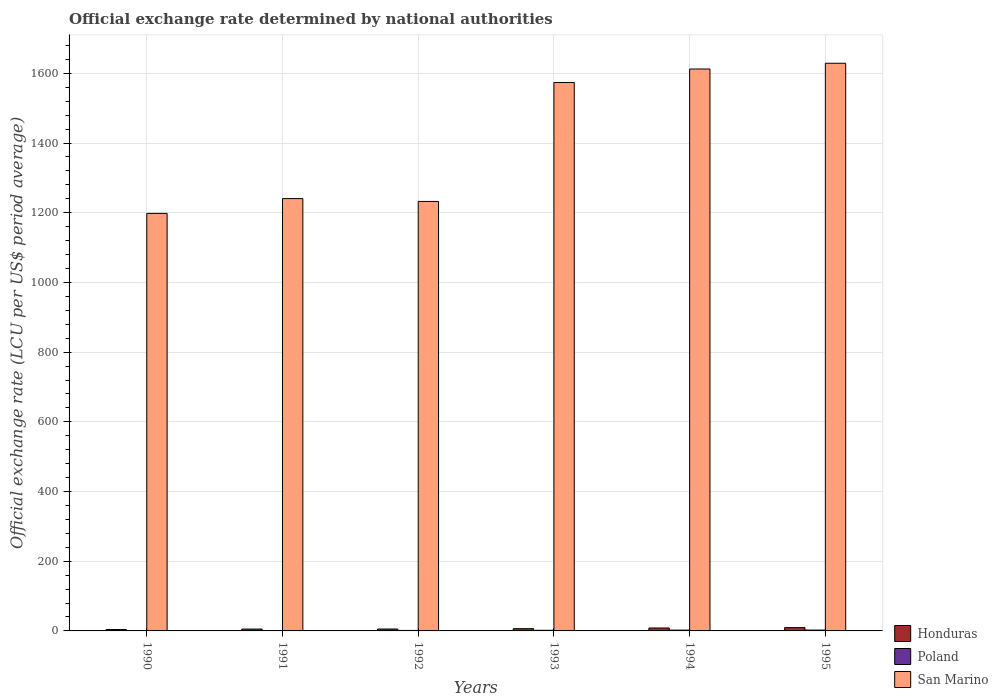How many different coloured bars are there?
Offer a terse response. 3. How many groups of bars are there?
Your answer should be compact. 6. How many bars are there on the 2nd tick from the right?
Keep it short and to the point. 3. What is the label of the 4th group of bars from the left?
Your answer should be compact. 1993. What is the official exchange rate in San Marino in 1992?
Make the answer very short. 1232.41. Across all years, what is the maximum official exchange rate in Poland?
Offer a very short reply. 2.42. Across all years, what is the minimum official exchange rate in Honduras?
Offer a very short reply. 4.11. What is the total official exchange rate in San Marino in the graph?
Give a very brief answer. 8486.16. What is the difference between the official exchange rate in Poland in 1991 and that in 1993?
Your answer should be very brief. -0.75. What is the difference between the official exchange rate in Honduras in 1991 and the official exchange rate in San Marino in 1994?
Your response must be concise. -1607.13. What is the average official exchange rate in Honduras per year?
Give a very brief answer. 6.55. In the year 1992, what is the difference between the official exchange rate in San Marino and official exchange rate in Honduras?
Ensure brevity in your answer.  1226.91. In how many years, is the official exchange rate in Honduras greater than 800 LCU?
Your response must be concise. 0. What is the ratio of the official exchange rate in Honduras in 1990 to that in 1995?
Offer a very short reply. 0.43. Is the official exchange rate in San Marino in 1990 less than that in 1991?
Give a very brief answer. Yes. What is the difference between the highest and the second highest official exchange rate in Poland?
Provide a succinct answer. 0.15. What is the difference between the highest and the lowest official exchange rate in Poland?
Keep it short and to the point. 1.47. In how many years, is the official exchange rate in Poland greater than the average official exchange rate in Poland taken over all years?
Provide a succinct answer. 3. Is the sum of the official exchange rate in Poland in 1994 and 1995 greater than the maximum official exchange rate in Honduras across all years?
Offer a terse response. No. What does the 2nd bar from the right in 1992 represents?
Your response must be concise. Poland. How many years are there in the graph?
Offer a very short reply. 6. Are the values on the major ticks of Y-axis written in scientific E-notation?
Offer a terse response. No. Where does the legend appear in the graph?
Ensure brevity in your answer.  Bottom right. What is the title of the graph?
Make the answer very short. Official exchange rate determined by national authorities. Does "Ukraine" appear as one of the legend labels in the graph?
Make the answer very short. No. What is the label or title of the X-axis?
Provide a succinct answer. Years. What is the label or title of the Y-axis?
Ensure brevity in your answer.  Official exchange rate (LCU per US$ period average). What is the Official exchange rate (LCU per US$ period average) of Honduras in 1990?
Keep it short and to the point. 4.11. What is the Official exchange rate (LCU per US$ period average) of Poland in 1990?
Provide a succinct answer. 0.95. What is the Official exchange rate (LCU per US$ period average) of San Marino in 1990?
Give a very brief answer. 1198.1. What is the Official exchange rate (LCU per US$ period average) in Honduras in 1991?
Provide a succinct answer. 5.32. What is the Official exchange rate (LCU per US$ period average) in Poland in 1991?
Give a very brief answer. 1.06. What is the Official exchange rate (LCU per US$ period average) of San Marino in 1991?
Offer a terse response. 1240.61. What is the Official exchange rate (LCU per US$ period average) in Honduras in 1992?
Make the answer very short. 5.5. What is the Official exchange rate (LCU per US$ period average) of Poland in 1992?
Ensure brevity in your answer.  1.36. What is the Official exchange rate (LCU per US$ period average) of San Marino in 1992?
Give a very brief answer. 1232.41. What is the Official exchange rate (LCU per US$ period average) of Honduras in 1993?
Provide a succinct answer. 6.47. What is the Official exchange rate (LCU per US$ period average) of Poland in 1993?
Provide a succinct answer. 1.81. What is the Official exchange rate (LCU per US$ period average) of San Marino in 1993?
Your answer should be compact. 1573.67. What is the Official exchange rate (LCU per US$ period average) in Honduras in 1994?
Your answer should be very brief. 8.41. What is the Official exchange rate (LCU per US$ period average) of Poland in 1994?
Provide a succinct answer. 2.27. What is the Official exchange rate (LCU per US$ period average) of San Marino in 1994?
Ensure brevity in your answer.  1612.44. What is the Official exchange rate (LCU per US$ period average) of Honduras in 1995?
Your answer should be very brief. 9.47. What is the Official exchange rate (LCU per US$ period average) of Poland in 1995?
Your answer should be compact. 2.42. What is the Official exchange rate (LCU per US$ period average) in San Marino in 1995?
Offer a very short reply. 1628.93. Across all years, what is the maximum Official exchange rate (LCU per US$ period average) of Honduras?
Ensure brevity in your answer.  9.47. Across all years, what is the maximum Official exchange rate (LCU per US$ period average) in Poland?
Your answer should be very brief. 2.42. Across all years, what is the maximum Official exchange rate (LCU per US$ period average) in San Marino?
Provide a short and direct response. 1628.93. Across all years, what is the minimum Official exchange rate (LCU per US$ period average) in Honduras?
Keep it short and to the point. 4.11. Across all years, what is the minimum Official exchange rate (LCU per US$ period average) of Poland?
Give a very brief answer. 0.95. Across all years, what is the minimum Official exchange rate (LCU per US$ period average) of San Marino?
Offer a terse response. 1198.1. What is the total Official exchange rate (LCU per US$ period average) of Honduras in the graph?
Make the answer very short. 39.28. What is the total Official exchange rate (LCU per US$ period average) of Poland in the graph?
Ensure brevity in your answer.  9.88. What is the total Official exchange rate (LCU per US$ period average) of San Marino in the graph?
Offer a very short reply. 8486.16. What is the difference between the Official exchange rate (LCU per US$ period average) in Honduras in 1990 and that in 1991?
Make the answer very short. -1.2. What is the difference between the Official exchange rate (LCU per US$ period average) in Poland in 1990 and that in 1991?
Provide a succinct answer. -0.11. What is the difference between the Official exchange rate (LCU per US$ period average) in San Marino in 1990 and that in 1991?
Provide a succinct answer. -42.51. What is the difference between the Official exchange rate (LCU per US$ period average) in Honduras in 1990 and that in 1992?
Offer a very short reply. -1.39. What is the difference between the Official exchange rate (LCU per US$ period average) of Poland in 1990 and that in 1992?
Offer a terse response. -0.41. What is the difference between the Official exchange rate (LCU per US$ period average) in San Marino in 1990 and that in 1992?
Keep it short and to the point. -34.3. What is the difference between the Official exchange rate (LCU per US$ period average) of Honduras in 1990 and that in 1993?
Your response must be concise. -2.36. What is the difference between the Official exchange rate (LCU per US$ period average) in Poland in 1990 and that in 1993?
Offer a very short reply. -0.86. What is the difference between the Official exchange rate (LCU per US$ period average) of San Marino in 1990 and that in 1993?
Ensure brevity in your answer.  -375.56. What is the difference between the Official exchange rate (LCU per US$ period average) in Honduras in 1990 and that in 1994?
Provide a short and direct response. -4.3. What is the difference between the Official exchange rate (LCU per US$ period average) of Poland in 1990 and that in 1994?
Provide a succinct answer. -1.32. What is the difference between the Official exchange rate (LCU per US$ period average) in San Marino in 1990 and that in 1994?
Your answer should be very brief. -414.34. What is the difference between the Official exchange rate (LCU per US$ period average) of Honduras in 1990 and that in 1995?
Provide a succinct answer. -5.36. What is the difference between the Official exchange rate (LCU per US$ period average) of Poland in 1990 and that in 1995?
Give a very brief answer. -1.48. What is the difference between the Official exchange rate (LCU per US$ period average) in San Marino in 1990 and that in 1995?
Make the answer very short. -430.83. What is the difference between the Official exchange rate (LCU per US$ period average) in Honduras in 1991 and that in 1992?
Offer a very short reply. -0.18. What is the difference between the Official exchange rate (LCU per US$ period average) of Poland in 1991 and that in 1992?
Offer a very short reply. -0.3. What is the difference between the Official exchange rate (LCU per US$ period average) of San Marino in 1991 and that in 1992?
Offer a very short reply. 8.21. What is the difference between the Official exchange rate (LCU per US$ period average) in Honduras in 1991 and that in 1993?
Ensure brevity in your answer.  -1.15. What is the difference between the Official exchange rate (LCU per US$ period average) of Poland in 1991 and that in 1993?
Provide a succinct answer. -0.75. What is the difference between the Official exchange rate (LCU per US$ period average) of San Marino in 1991 and that in 1993?
Your answer should be very brief. -333.05. What is the difference between the Official exchange rate (LCU per US$ period average) of Honduras in 1991 and that in 1994?
Provide a short and direct response. -3.09. What is the difference between the Official exchange rate (LCU per US$ period average) of Poland in 1991 and that in 1994?
Make the answer very short. -1.21. What is the difference between the Official exchange rate (LCU per US$ period average) of San Marino in 1991 and that in 1994?
Offer a terse response. -371.83. What is the difference between the Official exchange rate (LCU per US$ period average) of Honduras in 1991 and that in 1995?
Offer a terse response. -4.15. What is the difference between the Official exchange rate (LCU per US$ period average) of Poland in 1991 and that in 1995?
Your answer should be very brief. -1.37. What is the difference between the Official exchange rate (LCU per US$ period average) of San Marino in 1991 and that in 1995?
Make the answer very short. -388.32. What is the difference between the Official exchange rate (LCU per US$ period average) of Honduras in 1992 and that in 1993?
Your answer should be very brief. -0.97. What is the difference between the Official exchange rate (LCU per US$ period average) in Poland in 1992 and that in 1993?
Keep it short and to the point. -0.45. What is the difference between the Official exchange rate (LCU per US$ period average) of San Marino in 1992 and that in 1993?
Ensure brevity in your answer.  -341.26. What is the difference between the Official exchange rate (LCU per US$ period average) in Honduras in 1992 and that in 1994?
Make the answer very short. -2.91. What is the difference between the Official exchange rate (LCU per US$ period average) in Poland in 1992 and that in 1994?
Offer a terse response. -0.91. What is the difference between the Official exchange rate (LCU per US$ period average) in San Marino in 1992 and that in 1994?
Keep it short and to the point. -380.04. What is the difference between the Official exchange rate (LCU per US$ period average) in Honduras in 1992 and that in 1995?
Your response must be concise. -3.97. What is the difference between the Official exchange rate (LCU per US$ period average) in Poland in 1992 and that in 1995?
Offer a terse response. -1.06. What is the difference between the Official exchange rate (LCU per US$ period average) of San Marino in 1992 and that in 1995?
Provide a succinct answer. -396.53. What is the difference between the Official exchange rate (LCU per US$ period average) of Honduras in 1993 and that in 1994?
Keep it short and to the point. -1.94. What is the difference between the Official exchange rate (LCU per US$ period average) of Poland in 1993 and that in 1994?
Offer a very short reply. -0.46. What is the difference between the Official exchange rate (LCU per US$ period average) in San Marino in 1993 and that in 1994?
Offer a terse response. -38.78. What is the difference between the Official exchange rate (LCU per US$ period average) of Honduras in 1993 and that in 1995?
Ensure brevity in your answer.  -3. What is the difference between the Official exchange rate (LCU per US$ period average) of Poland in 1993 and that in 1995?
Keep it short and to the point. -0.61. What is the difference between the Official exchange rate (LCU per US$ period average) in San Marino in 1993 and that in 1995?
Offer a very short reply. -55.27. What is the difference between the Official exchange rate (LCU per US$ period average) in Honduras in 1994 and that in 1995?
Ensure brevity in your answer.  -1.06. What is the difference between the Official exchange rate (LCU per US$ period average) in Poland in 1994 and that in 1995?
Make the answer very short. -0.15. What is the difference between the Official exchange rate (LCU per US$ period average) of San Marino in 1994 and that in 1995?
Keep it short and to the point. -16.49. What is the difference between the Official exchange rate (LCU per US$ period average) of Honduras in 1990 and the Official exchange rate (LCU per US$ period average) of Poland in 1991?
Your answer should be compact. 3.05. What is the difference between the Official exchange rate (LCU per US$ period average) in Honduras in 1990 and the Official exchange rate (LCU per US$ period average) in San Marino in 1991?
Your response must be concise. -1236.5. What is the difference between the Official exchange rate (LCU per US$ period average) of Poland in 1990 and the Official exchange rate (LCU per US$ period average) of San Marino in 1991?
Your response must be concise. -1239.66. What is the difference between the Official exchange rate (LCU per US$ period average) of Honduras in 1990 and the Official exchange rate (LCU per US$ period average) of Poland in 1992?
Keep it short and to the point. 2.75. What is the difference between the Official exchange rate (LCU per US$ period average) of Honduras in 1990 and the Official exchange rate (LCU per US$ period average) of San Marino in 1992?
Ensure brevity in your answer.  -1228.29. What is the difference between the Official exchange rate (LCU per US$ period average) in Poland in 1990 and the Official exchange rate (LCU per US$ period average) in San Marino in 1992?
Your response must be concise. -1231.46. What is the difference between the Official exchange rate (LCU per US$ period average) in Honduras in 1990 and the Official exchange rate (LCU per US$ period average) in Poland in 1993?
Make the answer very short. 2.3. What is the difference between the Official exchange rate (LCU per US$ period average) of Honduras in 1990 and the Official exchange rate (LCU per US$ period average) of San Marino in 1993?
Your response must be concise. -1569.55. What is the difference between the Official exchange rate (LCU per US$ period average) in Poland in 1990 and the Official exchange rate (LCU per US$ period average) in San Marino in 1993?
Offer a terse response. -1572.72. What is the difference between the Official exchange rate (LCU per US$ period average) in Honduras in 1990 and the Official exchange rate (LCU per US$ period average) in Poland in 1994?
Your response must be concise. 1.84. What is the difference between the Official exchange rate (LCU per US$ period average) in Honduras in 1990 and the Official exchange rate (LCU per US$ period average) in San Marino in 1994?
Ensure brevity in your answer.  -1608.33. What is the difference between the Official exchange rate (LCU per US$ period average) of Poland in 1990 and the Official exchange rate (LCU per US$ period average) of San Marino in 1994?
Ensure brevity in your answer.  -1611.49. What is the difference between the Official exchange rate (LCU per US$ period average) in Honduras in 1990 and the Official exchange rate (LCU per US$ period average) in Poland in 1995?
Provide a short and direct response. 1.69. What is the difference between the Official exchange rate (LCU per US$ period average) in Honduras in 1990 and the Official exchange rate (LCU per US$ period average) in San Marino in 1995?
Make the answer very short. -1624.82. What is the difference between the Official exchange rate (LCU per US$ period average) in Poland in 1990 and the Official exchange rate (LCU per US$ period average) in San Marino in 1995?
Your response must be concise. -1627.98. What is the difference between the Official exchange rate (LCU per US$ period average) of Honduras in 1991 and the Official exchange rate (LCU per US$ period average) of Poland in 1992?
Give a very brief answer. 3.95. What is the difference between the Official exchange rate (LCU per US$ period average) of Honduras in 1991 and the Official exchange rate (LCU per US$ period average) of San Marino in 1992?
Give a very brief answer. -1227.09. What is the difference between the Official exchange rate (LCU per US$ period average) in Poland in 1991 and the Official exchange rate (LCU per US$ period average) in San Marino in 1992?
Offer a very short reply. -1231.35. What is the difference between the Official exchange rate (LCU per US$ period average) in Honduras in 1991 and the Official exchange rate (LCU per US$ period average) in Poland in 1993?
Ensure brevity in your answer.  3.51. What is the difference between the Official exchange rate (LCU per US$ period average) of Honduras in 1991 and the Official exchange rate (LCU per US$ period average) of San Marino in 1993?
Ensure brevity in your answer.  -1568.35. What is the difference between the Official exchange rate (LCU per US$ period average) in Poland in 1991 and the Official exchange rate (LCU per US$ period average) in San Marino in 1993?
Keep it short and to the point. -1572.61. What is the difference between the Official exchange rate (LCU per US$ period average) in Honduras in 1991 and the Official exchange rate (LCU per US$ period average) in Poland in 1994?
Make the answer very short. 3.04. What is the difference between the Official exchange rate (LCU per US$ period average) of Honduras in 1991 and the Official exchange rate (LCU per US$ period average) of San Marino in 1994?
Your response must be concise. -1607.13. What is the difference between the Official exchange rate (LCU per US$ period average) in Poland in 1991 and the Official exchange rate (LCU per US$ period average) in San Marino in 1994?
Your answer should be very brief. -1611.39. What is the difference between the Official exchange rate (LCU per US$ period average) in Honduras in 1991 and the Official exchange rate (LCU per US$ period average) in Poland in 1995?
Make the answer very short. 2.89. What is the difference between the Official exchange rate (LCU per US$ period average) of Honduras in 1991 and the Official exchange rate (LCU per US$ period average) of San Marino in 1995?
Your response must be concise. -1623.62. What is the difference between the Official exchange rate (LCU per US$ period average) in Poland in 1991 and the Official exchange rate (LCU per US$ period average) in San Marino in 1995?
Provide a succinct answer. -1627.88. What is the difference between the Official exchange rate (LCU per US$ period average) in Honduras in 1992 and the Official exchange rate (LCU per US$ period average) in Poland in 1993?
Provide a short and direct response. 3.69. What is the difference between the Official exchange rate (LCU per US$ period average) of Honduras in 1992 and the Official exchange rate (LCU per US$ period average) of San Marino in 1993?
Ensure brevity in your answer.  -1568.17. What is the difference between the Official exchange rate (LCU per US$ period average) of Poland in 1992 and the Official exchange rate (LCU per US$ period average) of San Marino in 1993?
Give a very brief answer. -1572.3. What is the difference between the Official exchange rate (LCU per US$ period average) in Honduras in 1992 and the Official exchange rate (LCU per US$ period average) in Poland in 1994?
Ensure brevity in your answer.  3.23. What is the difference between the Official exchange rate (LCU per US$ period average) of Honduras in 1992 and the Official exchange rate (LCU per US$ period average) of San Marino in 1994?
Give a very brief answer. -1606.95. What is the difference between the Official exchange rate (LCU per US$ period average) in Poland in 1992 and the Official exchange rate (LCU per US$ period average) in San Marino in 1994?
Keep it short and to the point. -1611.08. What is the difference between the Official exchange rate (LCU per US$ period average) in Honduras in 1992 and the Official exchange rate (LCU per US$ period average) in Poland in 1995?
Your answer should be very brief. 3.07. What is the difference between the Official exchange rate (LCU per US$ period average) in Honduras in 1992 and the Official exchange rate (LCU per US$ period average) in San Marino in 1995?
Keep it short and to the point. -1623.44. What is the difference between the Official exchange rate (LCU per US$ period average) in Poland in 1992 and the Official exchange rate (LCU per US$ period average) in San Marino in 1995?
Make the answer very short. -1627.57. What is the difference between the Official exchange rate (LCU per US$ period average) of Honduras in 1993 and the Official exchange rate (LCU per US$ period average) of Poland in 1994?
Offer a very short reply. 4.2. What is the difference between the Official exchange rate (LCU per US$ period average) in Honduras in 1993 and the Official exchange rate (LCU per US$ period average) in San Marino in 1994?
Your answer should be very brief. -1605.97. What is the difference between the Official exchange rate (LCU per US$ period average) of Poland in 1993 and the Official exchange rate (LCU per US$ period average) of San Marino in 1994?
Make the answer very short. -1610.63. What is the difference between the Official exchange rate (LCU per US$ period average) of Honduras in 1993 and the Official exchange rate (LCU per US$ period average) of Poland in 1995?
Offer a terse response. 4.05. What is the difference between the Official exchange rate (LCU per US$ period average) of Honduras in 1993 and the Official exchange rate (LCU per US$ period average) of San Marino in 1995?
Keep it short and to the point. -1622.46. What is the difference between the Official exchange rate (LCU per US$ period average) of Poland in 1993 and the Official exchange rate (LCU per US$ period average) of San Marino in 1995?
Provide a succinct answer. -1627.12. What is the difference between the Official exchange rate (LCU per US$ period average) of Honduras in 1994 and the Official exchange rate (LCU per US$ period average) of Poland in 1995?
Your answer should be compact. 5.98. What is the difference between the Official exchange rate (LCU per US$ period average) in Honduras in 1994 and the Official exchange rate (LCU per US$ period average) in San Marino in 1995?
Offer a terse response. -1620.52. What is the difference between the Official exchange rate (LCU per US$ period average) of Poland in 1994 and the Official exchange rate (LCU per US$ period average) of San Marino in 1995?
Offer a terse response. -1626.66. What is the average Official exchange rate (LCU per US$ period average) in Honduras per year?
Give a very brief answer. 6.55. What is the average Official exchange rate (LCU per US$ period average) of Poland per year?
Offer a terse response. 1.65. What is the average Official exchange rate (LCU per US$ period average) of San Marino per year?
Offer a terse response. 1414.36. In the year 1990, what is the difference between the Official exchange rate (LCU per US$ period average) in Honduras and Official exchange rate (LCU per US$ period average) in Poland?
Your answer should be very brief. 3.16. In the year 1990, what is the difference between the Official exchange rate (LCU per US$ period average) in Honduras and Official exchange rate (LCU per US$ period average) in San Marino?
Ensure brevity in your answer.  -1193.99. In the year 1990, what is the difference between the Official exchange rate (LCU per US$ period average) in Poland and Official exchange rate (LCU per US$ period average) in San Marino?
Offer a very short reply. -1197.15. In the year 1991, what is the difference between the Official exchange rate (LCU per US$ period average) of Honduras and Official exchange rate (LCU per US$ period average) of Poland?
Ensure brevity in your answer.  4.26. In the year 1991, what is the difference between the Official exchange rate (LCU per US$ period average) of Honduras and Official exchange rate (LCU per US$ period average) of San Marino?
Ensure brevity in your answer.  -1235.3. In the year 1991, what is the difference between the Official exchange rate (LCU per US$ period average) in Poland and Official exchange rate (LCU per US$ period average) in San Marino?
Your response must be concise. -1239.56. In the year 1992, what is the difference between the Official exchange rate (LCU per US$ period average) of Honduras and Official exchange rate (LCU per US$ period average) of Poland?
Ensure brevity in your answer.  4.14. In the year 1992, what is the difference between the Official exchange rate (LCU per US$ period average) in Honduras and Official exchange rate (LCU per US$ period average) in San Marino?
Ensure brevity in your answer.  -1226.91. In the year 1992, what is the difference between the Official exchange rate (LCU per US$ period average) of Poland and Official exchange rate (LCU per US$ period average) of San Marino?
Offer a very short reply. -1231.04. In the year 1993, what is the difference between the Official exchange rate (LCU per US$ period average) in Honduras and Official exchange rate (LCU per US$ period average) in Poland?
Make the answer very short. 4.66. In the year 1993, what is the difference between the Official exchange rate (LCU per US$ period average) in Honduras and Official exchange rate (LCU per US$ period average) in San Marino?
Your response must be concise. -1567.19. In the year 1993, what is the difference between the Official exchange rate (LCU per US$ period average) of Poland and Official exchange rate (LCU per US$ period average) of San Marino?
Your answer should be compact. -1571.85. In the year 1994, what is the difference between the Official exchange rate (LCU per US$ period average) of Honduras and Official exchange rate (LCU per US$ period average) of Poland?
Your answer should be compact. 6.14. In the year 1994, what is the difference between the Official exchange rate (LCU per US$ period average) of Honduras and Official exchange rate (LCU per US$ period average) of San Marino?
Ensure brevity in your answer.  -1604.04. In the year 1994, what is the difference between the Official exchange rate (LCU per US$ period average) of Poland and Official exchange rate (LCU per US$ period average) of San Marino?
Ensure brevity in your answer.  -1610.17. In the year 1995, what is the difference between the Official exchange rate (LCU per US$ period average) in Honduras and Official exchange rate (LCU per US$ period average) in Poland?
Ensure brevity in your answer.  7.05. In the year 1995, what is the difference between the Official exchange rate (LCU per US$ period average) of Honduras and Official exchange rate (LCU per US$ period average) of San Marino?
Make the answer very short. -1619.46. In the year 1995, what is the difference between the Official exchange rate (LCU per US$ period average) of Poland and Official exchange rate (LCU per US$ period average) of San Marino?
Provide a succinct answer. -1626.51. What is the ratio of the Official exchange rate (LCU per US$ period average) of Honduras in 1990 to that in 1991?
Make the answer very short. 0.77. What is the ratio of the Official exchange rate (LCU per US$ period average) in Poland in 1990 to that in 1991?
Offer a very short reply. 0.9. What is the ratio of the Official exchange rate (LCU per US$ period average) of San Marino in 1990 to that in 1991?
Provide a short and direct response. 0.97. What is the ratio of the Official exchange rate (LCU per US$ period average) of Honduras in 1990 to that in 1992?
Your answer should be compact. 0.75. What is the ratio of the Official exchange rate (LCU per US$ period average) of Poland in 1990 to that in 1992?
Ensure brevity in your answer.  0.7. What is the ratio of the Official exchange rate (LCU per US$ period average) of San Marino in 1990 to that in 1992?
Your answer should be compact. 0.97. What is the ratio of the Official exchange rate (LCU per US$ period average) in Honduras in 1990 to that in 1993?
Make the answer very short. 0.64. What is the ratio of the Official exchange rate (LCU per US$ period average) in Poland in 1990 to that in 1993?
Offer a very short reply. 0.52. What is the ratio of the Official exchange rate (LCU per US$ period average) in San Marino in 1990 to that in 1993?
Ensure brevity in your answer.  0.76. What is the ratio of the Official exchange rate (LCU per US$ period average) of Honduras in 1990 to that in 1994?
Your answer should be very brief. 0.49. What is the ratio of the Official exchange rate (LCU per US$ period average) in Poland in 1990 to that in 1994?
Ensure brevity in your answer.  0.42. What is the ratio of the Official exchange rate (LCU per US$ period average) in San Marino in 1990 to that in 1994?
Ensure brevity in your answer.  0.74. What is the ratio of the Official exchange rate (LCU per US$ period average) of Honduras in 1990 to that in 1995?
Ensure brevity in your answer.  0.43. What is the ratio of the Official exchange rate (LCU per US$ period average) of Poland in 1990 to that in 1995?
Make the answer very short. 0.39. What is the ratio of the Official exchange rate (LCU per US$ period average) of San Marino in 1990 to that in 1995?
Provide a succinct answer. 0.74. What is the ratio of the Official exchange rate (LCU per US$ period average) in Honduras in 1991 to that in 1992?
Give a very brief answer. 0.97. What is the ratio of the Official exchange rate (LCU per US$ period average) of Poland in 1991 to that in 1992?
Your response must be concise. 0.78. What is the ratio of the Official exchange rate (LCU per US$ period average) in Honduras in 1991 to that in 1993?
Make the answer very short. 0.82. What is the ratio of the Official exchange rate (LCU per US$ period average) of Poland in 1991 to that in 1993?
Your response must be concise. 0.58. What is the ratio of the Official exchange rate (LCU per US$ period average) in San Marino in 1991 to that in 1993?
Provide a short and direct response. 0.79. What is the ratio of the Official exchange rate (LCU per US$ period average) of Honduras in 1991 to that in 1994?
Give a very brief answer. 0.63. What is the ratio of the Official exchange rate (LCU per US$ period average) of Poland in 1991 to that in 1994?
Provide a short and direct response. 0.47. What is the ratio of the Official exchange rate (LCU per US$ period average) in San Marino in 1991 to that in 1994?
Your answer should be compact. 0.77. What is the ratio of the Official exchange rate (LCU per US$ period average) of Honduras in 1991 to that in 1995?
Ensure brevity in your answer.  0.56. What is the ratio of the Official exchange rate (LCU per US$ period average) in Poland in 1991 to that in 1995?
Keep it short and to the point. 0.44. What is the ratio of the Official exchange rate (LCU per US$ period average) of San Marino in 1991 to that in 1995?
Provide a short and direct response. 0.76. What is the ratio of the Official exchange rate (LCU per US$ period average) in Honduras in 1992 to that in 1993?
Give a very brief answer. 0.85. What is the ratio of the Official exchange rate (LCU per US$ period average) in Poland in 1992 to that in 1993?
Your answer should be very brief. 0.75. What is the ratio of the Official exchange rate (LCU per US$ period average) of San Marino in 1992 to that in 1993?
Provide a short and direct response. 0.78. What is the ratio of the Official exchange rate (LCU per US$ period average) in Honduras in 1992 to that in 1994?
Ensure brevity in your answer.  0.65. What is the ratio of the Official exchange rate (LCU per US$ period average) in Poland in 1992 to that in 1994?
Offer a terse response. 0.6. What is the ratio of the Official exchange rate (LCU per US$ period average) in San Marino in 1992 to that in 1994?
Keep it short and to the point. 0.76. What is the ratio of the Official exchange rate (LCU per US$ period average) in Honduras in 1992 to that in 1995?
Your response must be concise. 0.58. What is the ratio of the Official exchange rate (LCU per US$ period average) in Poland in 1992 to that in 1995?
Offer a terse response. 0.56. What is the ratio of the Official exchange rate (LCU per US$ period average) in San Marino in 1992 to that in 1995?
Provide a short and direct response. 0.76. What is the ratio of the Official exchange rate (LCU per US$ period average) in Honduras in 1993 to that in 1994?
Offer a terse response. 0.77. What is the ratio of the Official exchange rate (LCU per US$ period average) in Poland in 1993 to that in 1994?
Your response must be concise. 0.8. What is the ratio of the Official exchange rate (LCU per US$ period average) in Honduras in 1993 to that in 1995?
Ensure brevity in your answer.  0.68. What is the ratio of the Official exchange rate (LCU per US$ period average) of Poland in 1993 to that in 1995?
Make the answer very short. 0.75. What is the ratio of the Official exchange rate (LCU per US$ period average) of San Marino in 1993 to that in 1995?
Your answer should be very brief. 0.97. What is the ratio of the Official exchange rate (LCU per US$ period average) of Honduras in 1994 to that in 1995?
Give a very brief answer. 0.89. What is the ratio of the Official exchange rate (LCU per US$ period average) in Poland in 1994 to that in 1995?
Keep it short and to the point. 0.94. What is the ratio of the Official exchange rate (LCU per US$ period average) in San Marino in 1994 to that in 1995?
Give a very brief answer. 0.99. What is the difference between the highest and the second highest Official exchange rate (LCU per US$ period average) of Honduras?
Make the answer very short. 1.06. What is the difference between the highest and the second highest Official exchange rate (LCU per US$ period average) of Poland?
Keep it short and to the point. 0.15. What is the difference between the highest and the second highest Official exchange rate (LCU per US$ period average) in San Marino?
Give a very brief answer. 16.49. What is the difference between the highest and the lowest Official exchange rate (LCU per US$ period average) of Honduras?
Ensure brevity in your answer.  5.36. What is the difference between the highest and the lowest Official exchange rate (LCU per US$ period average) of Poland?
Provide a succinct answer. 1.48. What is the difference between the highest and the lowest Official exchange rate (LCU per US$ period average) of San Marino?
Provide a short and direct response. 430.83. 